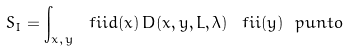Convert formula to latex. <formula><loc_0><loc_0><loc_500><loc_500>S _ { I } = \int _ { x , \, y } \ f i i d ( x ) \, D ( x , y , L , \lambda ) \, \ f i i ( y ) \ p u n t o</formula> 